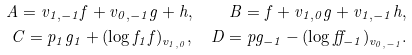Convert formula to latex. <formula><loc_0><loc_0><loc_500><loc_500>A = v _ { 1 , - 1 } f + v _ { 0 , - 1 } g + h , \quad B = f + v _ { 1 , 0 } g + v _ { 1 , - 1 } h , \\ C = p _ { 1 } g _ { 1 } + ( \log f _ { 1 } f ) _ { v _ { 1 , 0 } } , \quad D = p g _ { - 1 } - ( \log f f _ { - 1 } ) _ { v _ { 0 , - 1 } } .</formula> 